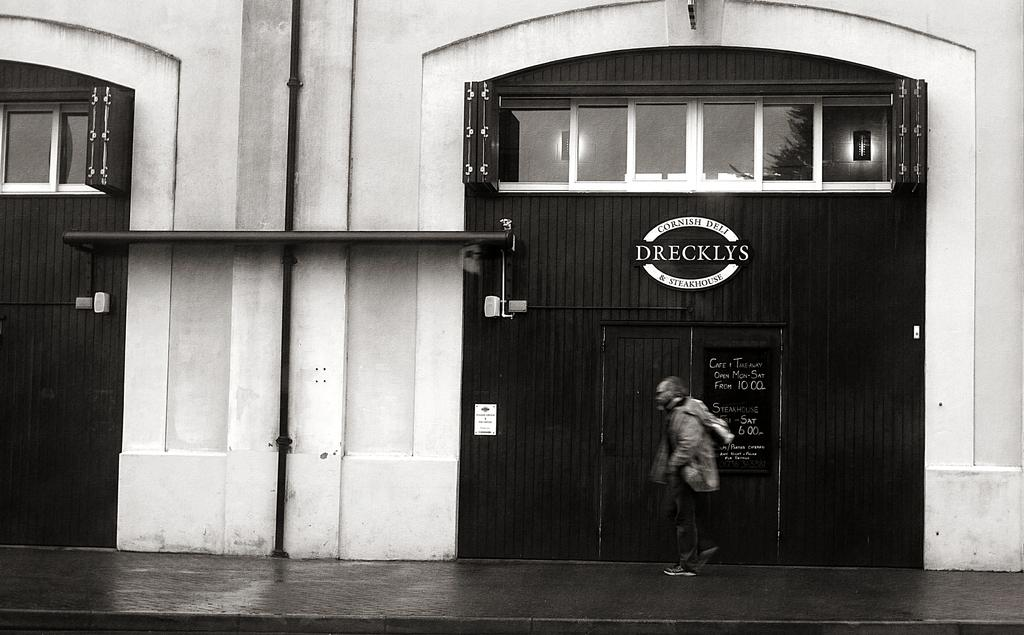Who or what is in the image? There is a person in the image. What is the person doing in the image? The person is standing in front of a door. What can be seen behind the person? There is a building visible behind the person. What type of crime is being committed in the image? There is no indication of a crime being committed in the image. The person is simply standing in front of a door. 